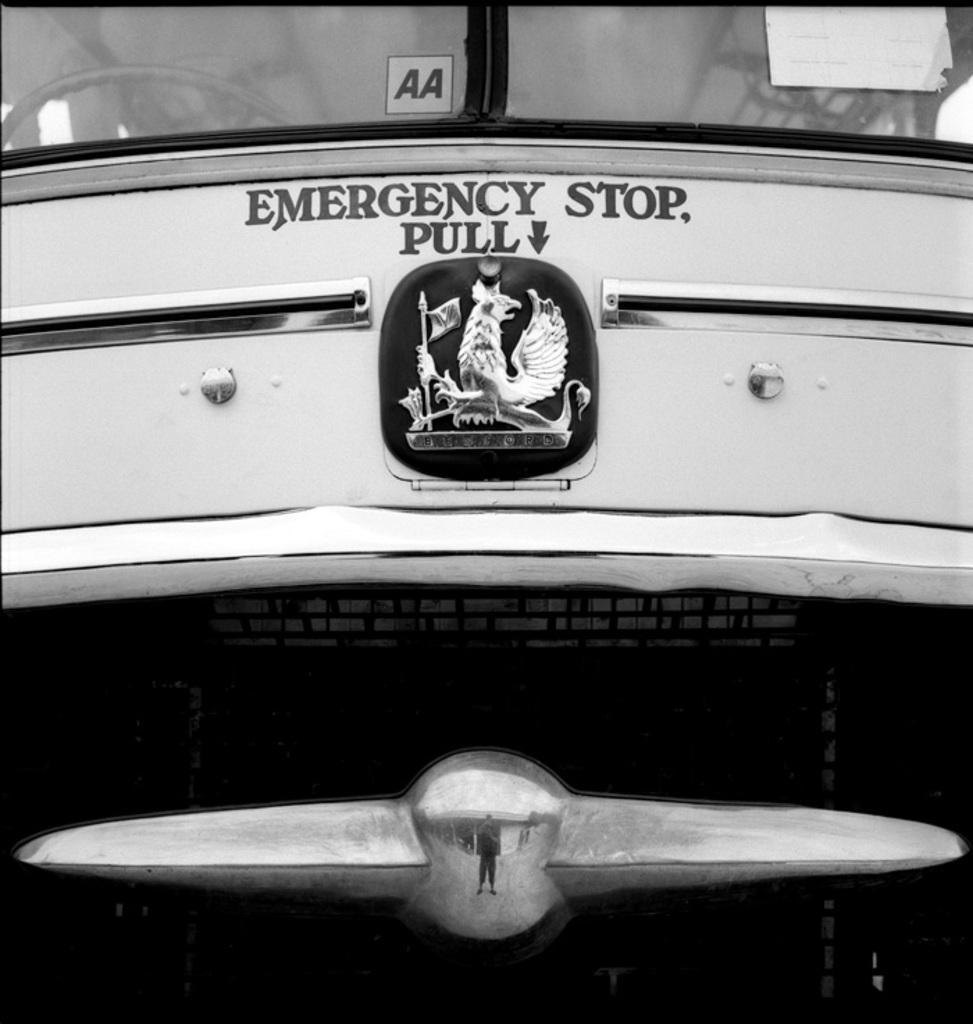<image>
Relay a brief, clear account of the picture shown. Emergency Stop pull message on top of the car emblem. 